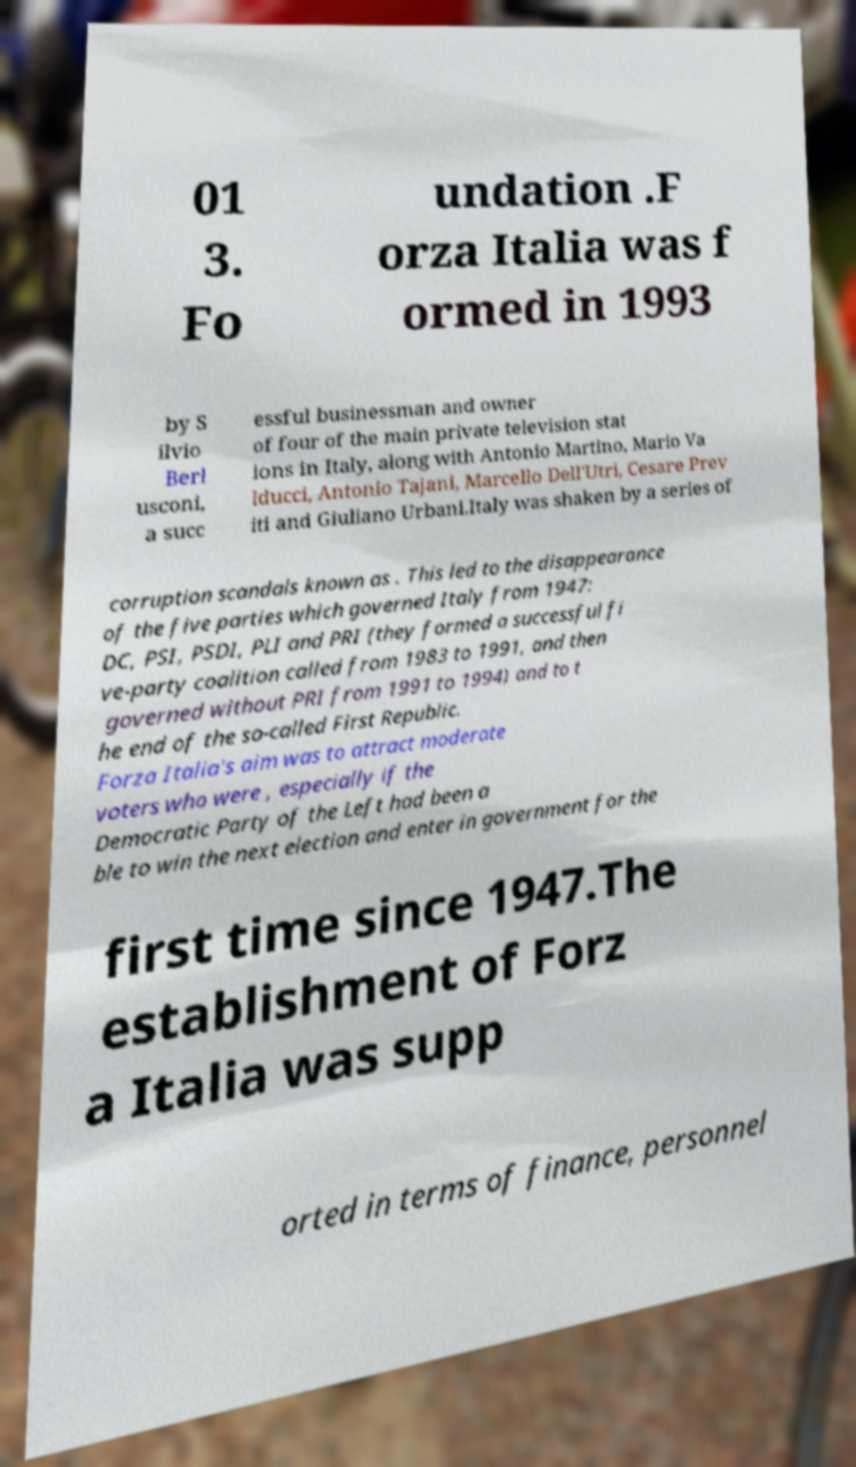Please read and relay the text visible in this image. What does it say? 01 3. Fo undation .F orza Italia was f ormed in 1993 by S ilvio Berl usconi, a succ essful businessman and owner of four of the main private television stat ions in Italy, along with Antonio Martino, Mario Va lducci, Antonio Tajani, Marcello Dell'Utri, Cesare Prev iti and Giuliano Urbani.Italy was shaken by a series of corruption scandals known as . This led to the disappearance of the five parties which governed Italy from 1947: DC, PSI, PSDI, PLI and PRI (they formed a successful fi ve-party coalition called from 1983 to 1991, and then governed without PRI from 1991 to 1994) and to t he end of the so-called First Republic. Forza Italia's aim was to attract moderate voters who were , especially if the Democratic Party of the Left had been a ble to win the next election and enter in government for the first time since 1947.The establishment of Forz a Italia was supp orted in terms of finance, personnel 